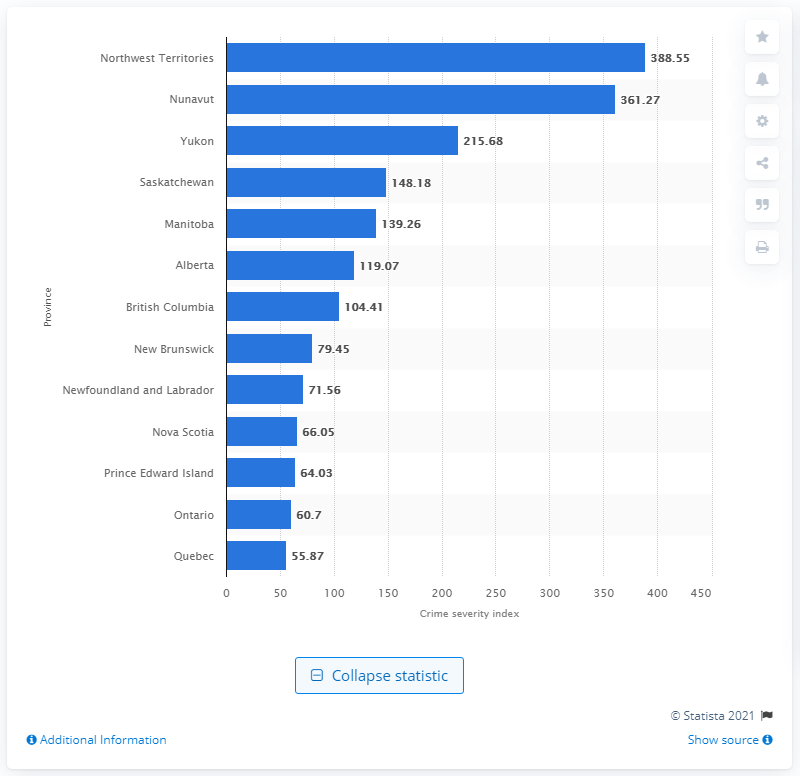Specify some key components in this picture. In 2019, the Crime Severity Index in the Northwest Territories was 388.55. 